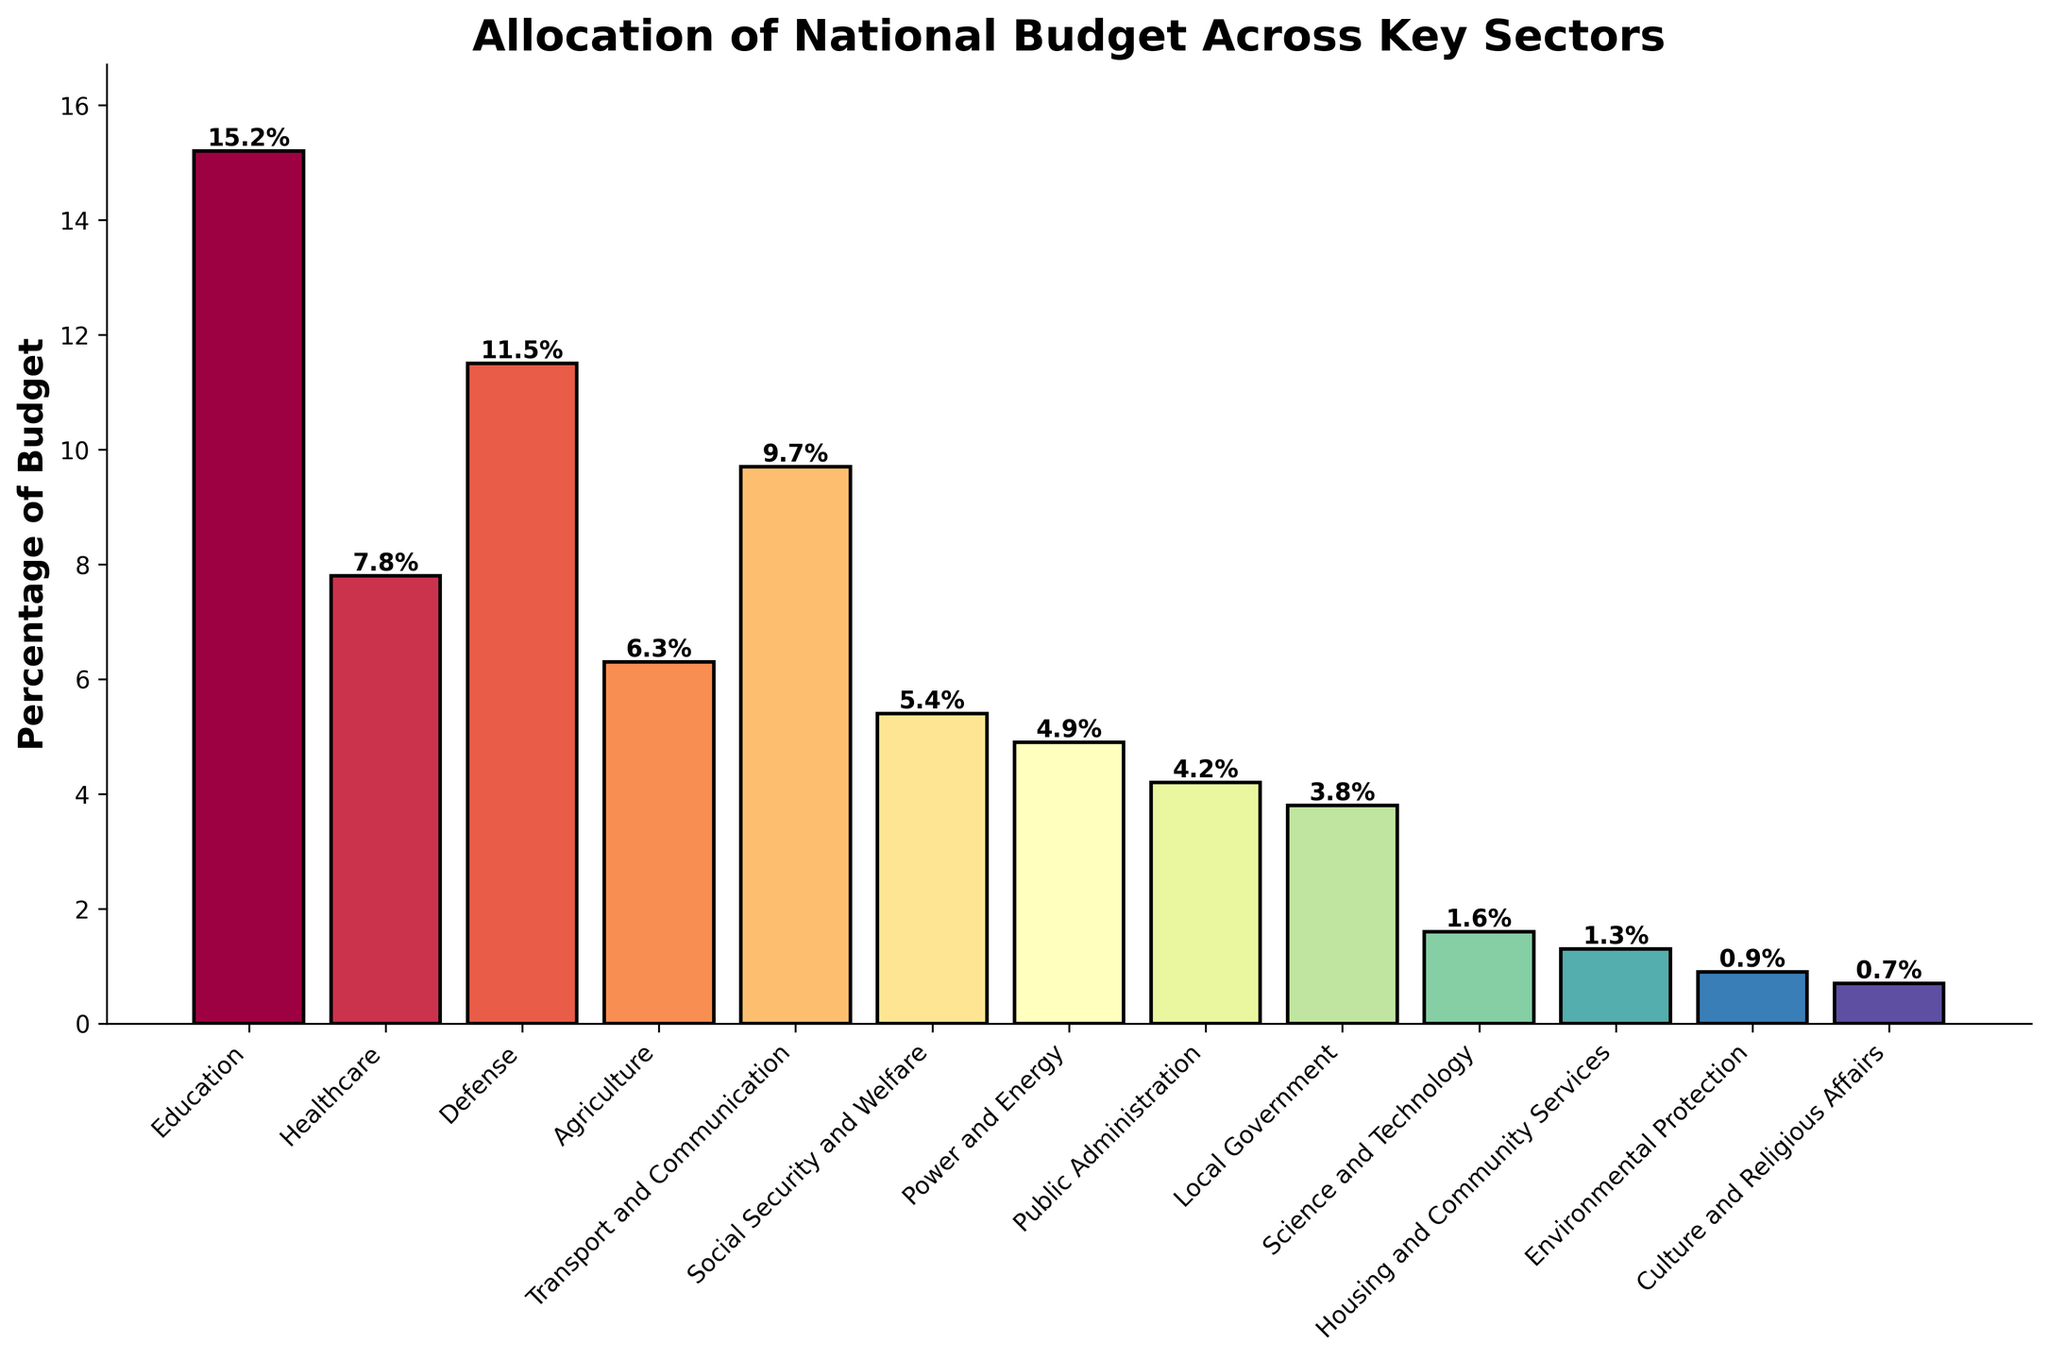Which sector received the highest percentage of the national budget? The bar representing 'Education' is the tallest, indicating it received the highest percentage of the national budget.
Answer: Education What is the combined budget percentage for 'Defense' and 'Healthcare'? Add the percentages allocated to 'Defense' (11.5%) and 'Healthcare' (7.8%). The sum is 11.5 + 7.8 = 19.3%.
Answer: 19.3% How much more budget percentage was allocated to 'Education' than 'Agriculture'? Subtract the percentage for 'Agriculture' (6.3%) from the percentage for 'Education' (15.2%). The difference is 15.2 - 6.3 = 8.9%.
Answer: 8.9% Which sector has the lowest percentage allocation, and what is the value? The bar for 'Culture and Religious Affairs' is the shortest indicating it has the lowest allocation at 0.7%.
Answer: Culture and Religious Affairs and 0.7% Is the budget percentage for 'Transport and Communication' greater than that for 'Power and Energy'? Compare the percentages: 'Transport and Communication' (9.7%) is greater than 'Power and Energy' (4.9%).
Answer: Yes Which sectors have budget allocations less than 5%? Sectors with percentages under 5% are 'Power and Energy' (4.9%), 'Public Administration' (4.2%), 'Local Government' (3.8%), 'Science and Technology' (1.6%), 'Housing and Community Services' (1.3%), 'Environmental Protection' (0.9%), and 'Culture and Religious Affairs' (0.7%).
Answer: Power and Energy, Public Administration, Local Government, Science and Technology, Housing and Community Services, Environmental Protection, Culture and Religious Affairs What is the average budget percentage of 'Social Security and Welfare', 'Public Administration', and 'Local Government'? Add the percentages for the three sectors and divide by 3. (5.4% + 4.2% + 3.8%) / 3 = 13.4 / 3 = 4.47%.
Answer: 4.47% Is the budget allocation for 'Defense' closer to 'Transport and Communication' or 'Healthcare'? Calculate the differences: between 'Defense' (11.5%) and 'Transport and Communication' (9.7%) it is 1.8%; between 'Defense' and 'Healthcare' (7.8%) it is 3.7%. 'Defense' is closer to 'Transport and Communication'.
Answer: Transport and Communication What sectors make up more than 10% of the budget individually? Sectors with allocations above 10% are 'Education' (15.2%) and 'Defense' (11.5%).
Answer: Education and Defense How does the budget for 'Science and Technology' compare to the budget for 'Environmental Protection'? Compare the percentages: 'Science and Technology' has 1.6%, and 'Environmental Protection' has 0.9%. 'Science and Technology' has a higher allocation.
Answer: Science and Technology has a higher allocation 